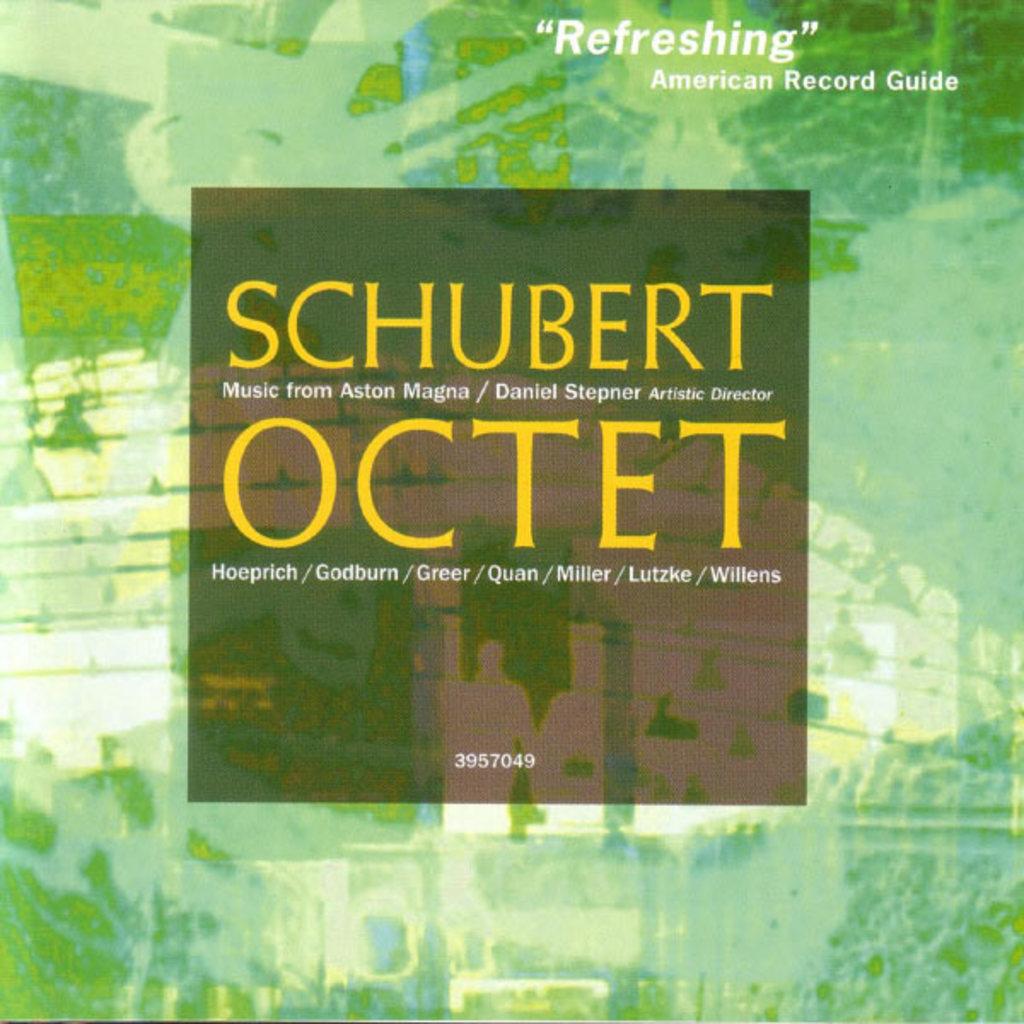What is the name on the glass?
Provide a succinct answer. Schubert. Who said it was refreshing?
Offer a terse response. American record guide. 